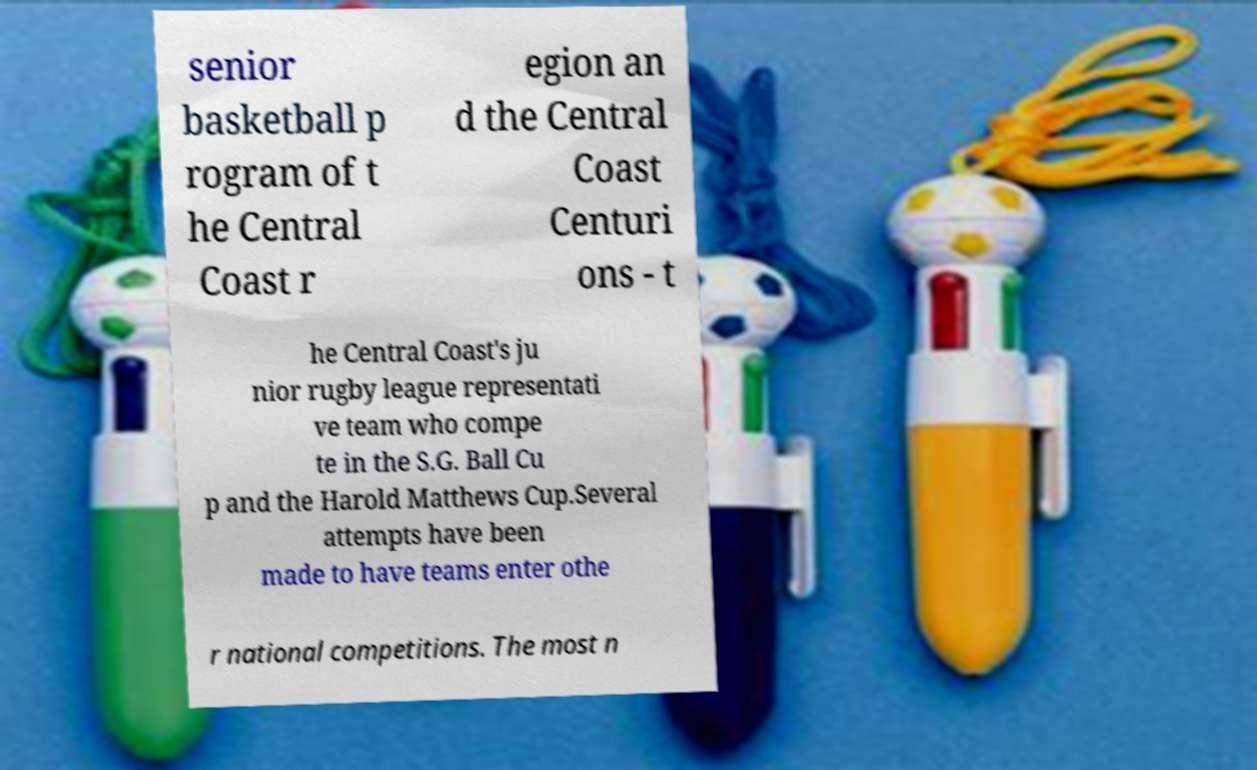What messages or text are displayed in this image? I need them in a readable, typed format. senior basketball p rogram of t he Central Coast r egion an d the Central Coast Centuri ons - t he Central Coast's ju nior rugby league representati ve team who compe te in the S.G. Ball Cu p and the Harold Matthews Cup.Several attempts have been made to have teams enter othe r national competitions. The most n 